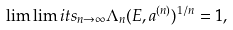<formula> <loc_0><loc_0><loc_500><loc_500>\lim \lim i t s _ { n \rightarrow \infty } \Lambda _ { n } ( E , a ^ { ( n ) } ) ^ { 1 / n } = 1 ,</formula> 